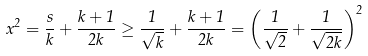<formula> <loc_0><loc_0><loc_500><loc_500>x ^ { 2 } = \frac { s } { k } + \frac { k + 1 } { 2 k } \geq \frac { 1 } { \sqrt { k } } + \frac { k + 1 } { 2 k } = \left ( \frac { 1 } { \sqrt { 2 } } + \frac { 1 } { \sqrt { 2 k } } \right ) ^ { 2 }</formula> 